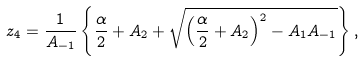Convert formula to latex. <formula><loc_0><loc_0><loc_500><loc_500>z _ { 4 } = \frac { 1 } { A _ { - 1 } } \left \{ \frac { \alpha } { 2 } + A _ { 2 } + \sqrt { \left ( \frac { \alpha } { 2 } + A _ { 2 } \right ) ^ { 2 } - A _ { 1 } A _ { - 1 } } \right \} ,</formula> 